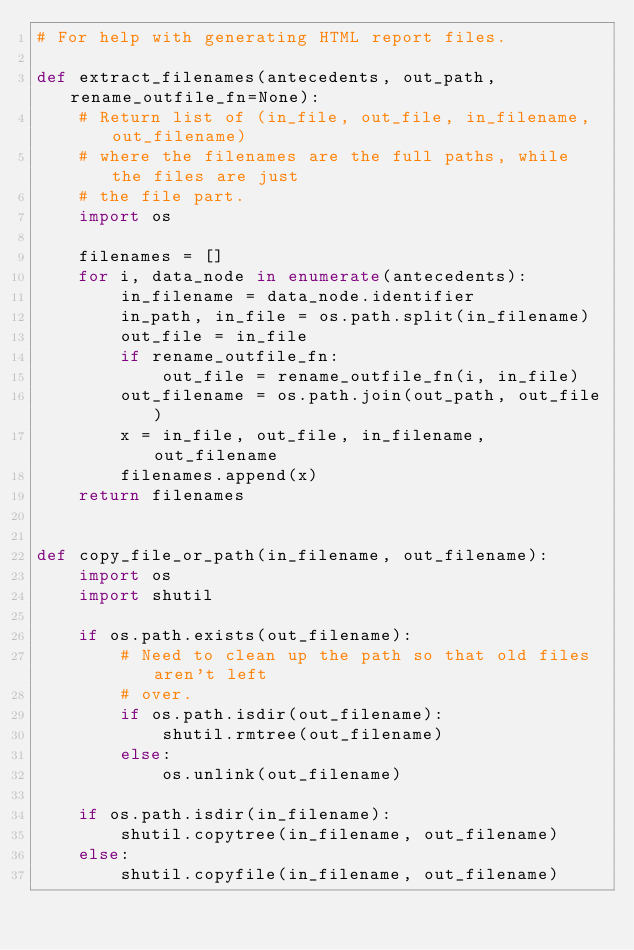<code> <loc_0><loc_0><loc_500><loc_500><_Python_># For help with generating HTML report files.

def extract_filenames(antecedents, out_path, rename_outfile_fn=None):
    # Return list of (in_file, out_file, in_filename, out_filename)
    # where the filenames are the full paths, while the files are just
    # the file part.
    import os
    
    filenames = []
    for i, data_node in enumerate(antecedents):
        in_filename = data_node.identifier
        in_path, in_file = os.path.split(in_filename)
        out_file = in_file
        if rename_outfile_fn:
            out_file = rename_outfile_fn(i, in_file)
        out_filename = os.path.join(out_path, out_file)
        x = in_file, out_file, in_filename, out_filename
        filenames.append(x)
    return filenames


def copy_file_or_path(in_filename, out_filename):
    import os
    import shutil

    if os.path.exists(out_filename):
        # Need to clean up the path so that old files aren't left
        # over.
        if os.path.isdir(out_filename):
            shutil.rmtree(out_filename)
        else:
            os.unlink(out_filename)
    
    if os.path.isdir(in_filename):
        shutil.copytree(in_filename, out_filename)
    else:
        shutil.copyfile(in_filename, out_filename)
</code> 